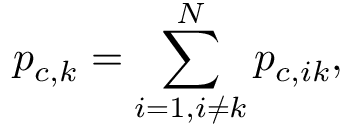Convert formula to latex. <formula><loc_0><loc_0><loc_500><loc_500>p _ { c , k } = \sum _ { i = 1 , i \neq k } ^ { N } p _ { c , i k } ,</formula> 